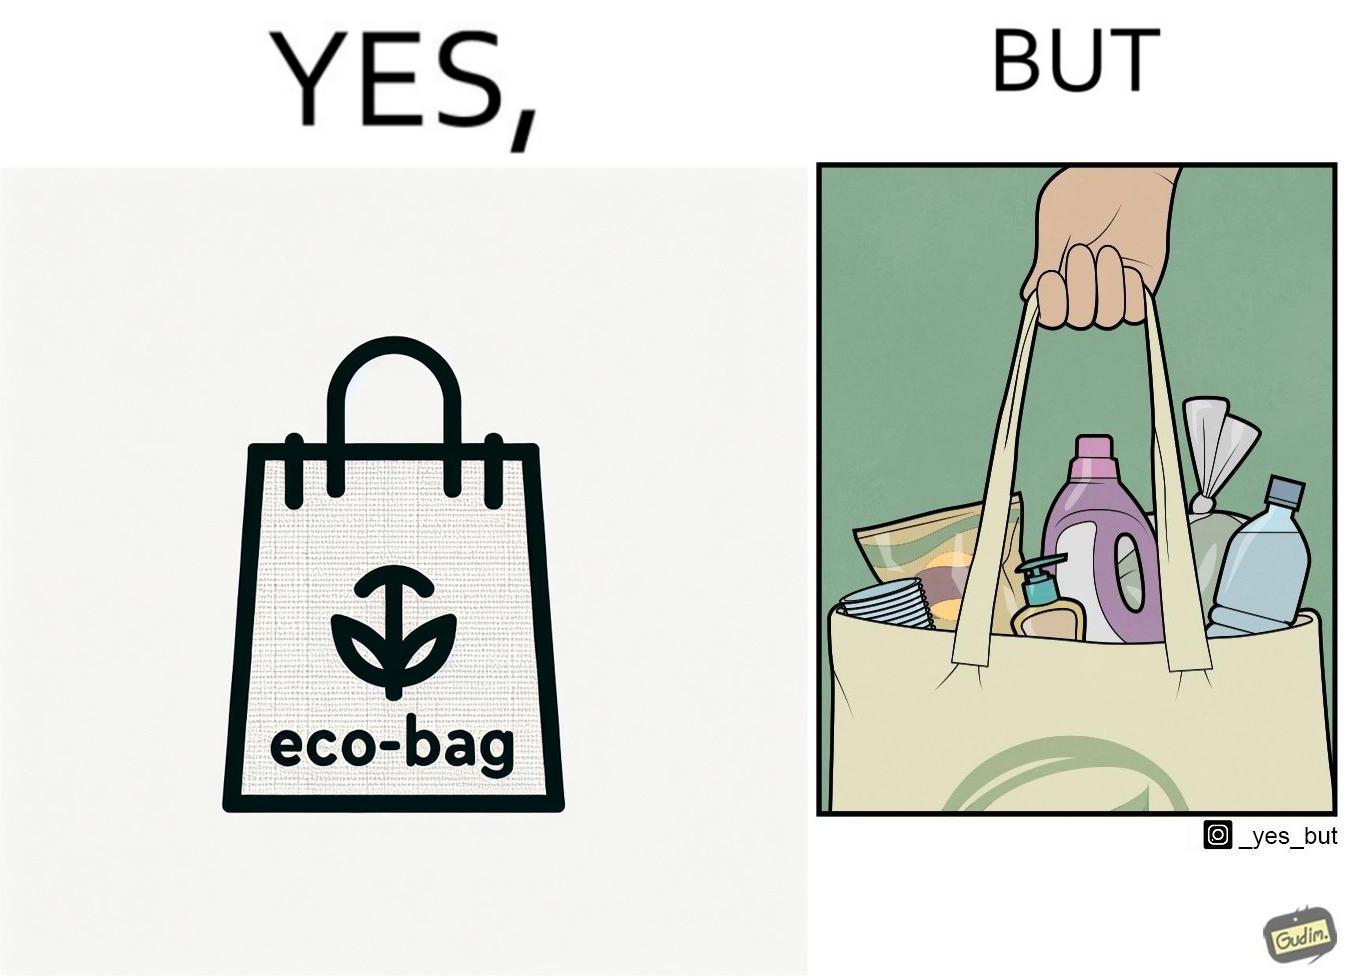What makes this image funny or satirical? The image is ironic, because people nowadays use eco-bag thinking them as safe for the environment but in turn use products which are harmful for the environment or are packaged in some non-biodegradable material 